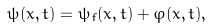Convert formula to latex. <formula><loc_0><loc_0><loc_500><loc_500>\psi ( x , t ) = \psi _ { f } ( x , t ) + \varphi ( x , t ) ,</formula> 